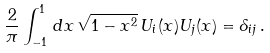Convert formula to latex. <formula><loc_0><loc_0><loc_500><loc_500>\frac { 2 } { \pi } \int _ { - 1 } ^ { 1 } \, d x \, \sqrt { 1 - x ^ { 2 } } \, U _ { i } ( x ) U _ { j } ( x ) = \delta _ { i j } \, .</formula> 